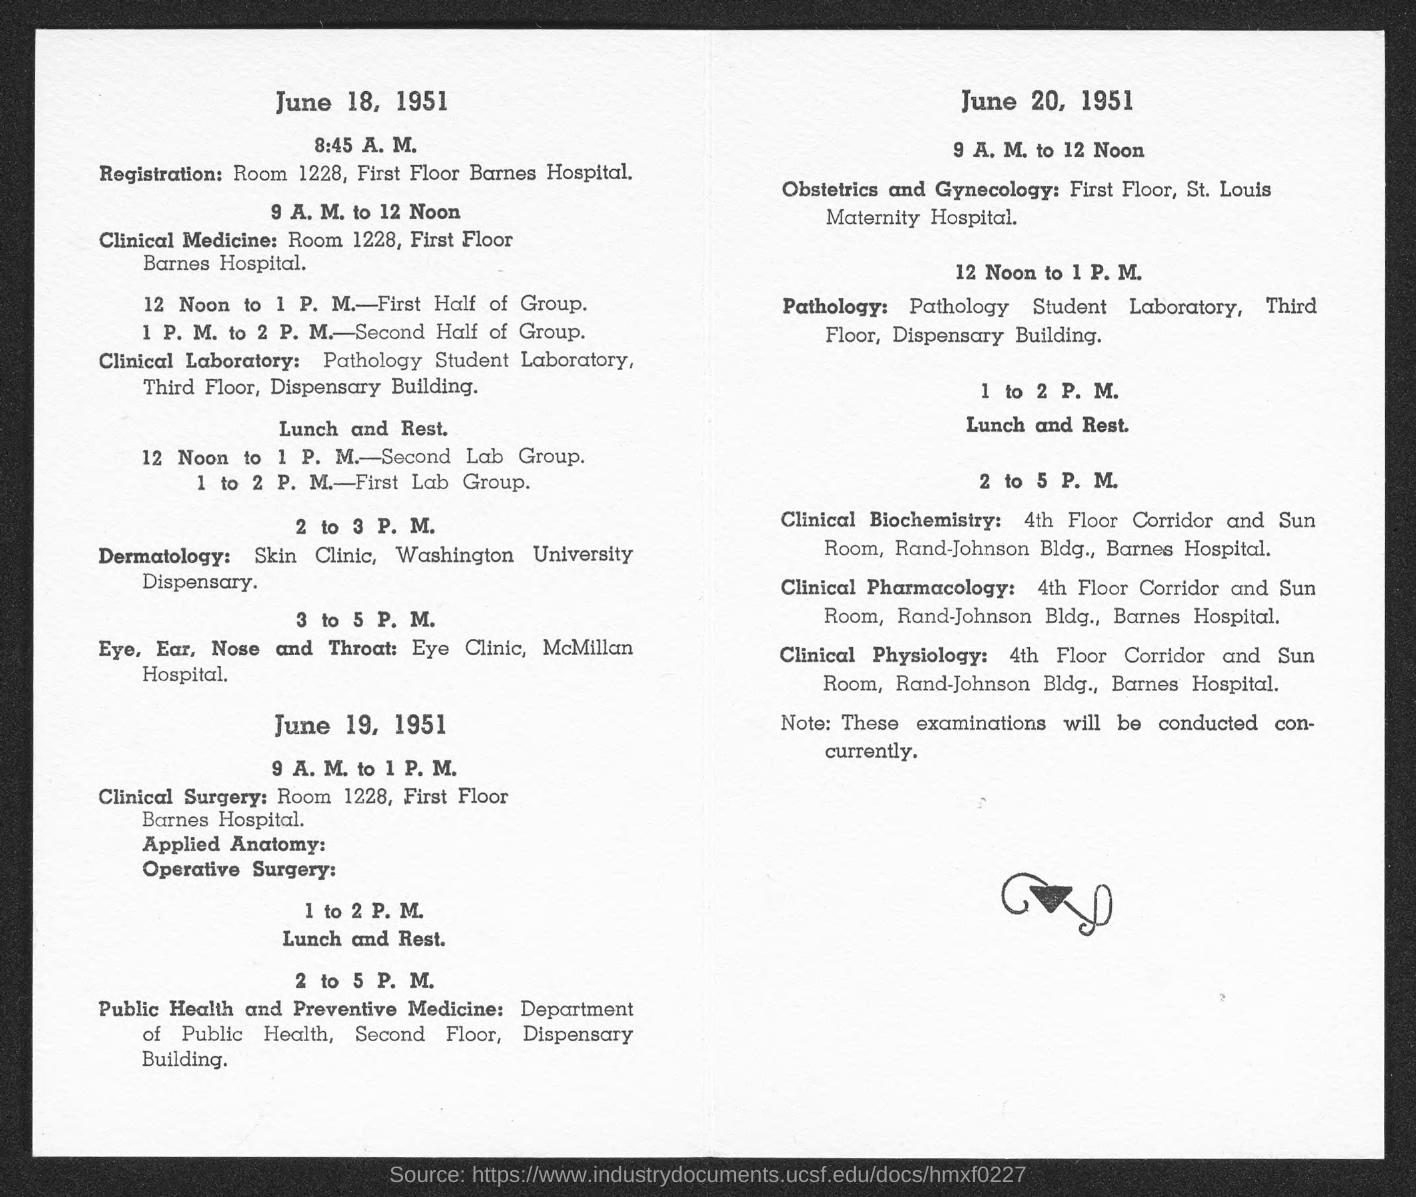At what building the pathology is located?
Offer a terse response. Dispensary Building. At what floor the clinical pharmacology is?
Ensure brevity in your answer.  4th Floor. 